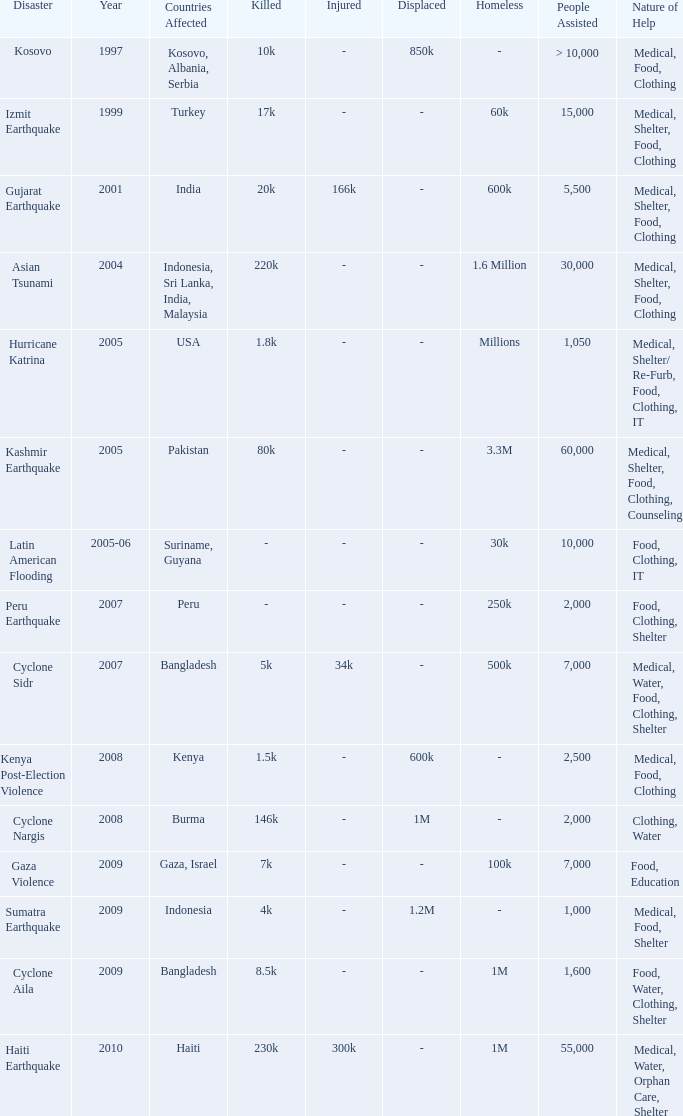During which year did a calamity occur in the usa? 2005.0. 